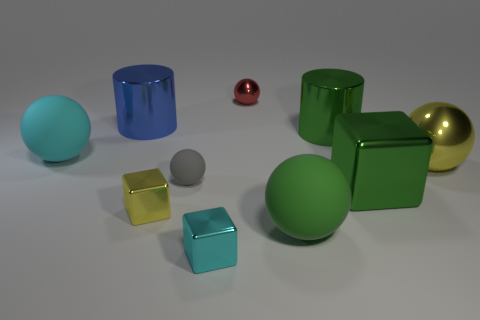Subtract all purple balls. Subtract all red cylinders. How many balls are left? 5 Subtract all blocks. How many objects are left? 7 Subtract 1 cyan spheres. How many objects are left? 9 Subtract all big balls. Subtract all large blue cylinders. How many objects are left? 6 Add 6 large blocks. How many large blocks are left? 7 Add 8 big green metallic cylinders. How many big green metallic cylinders exist? 9 